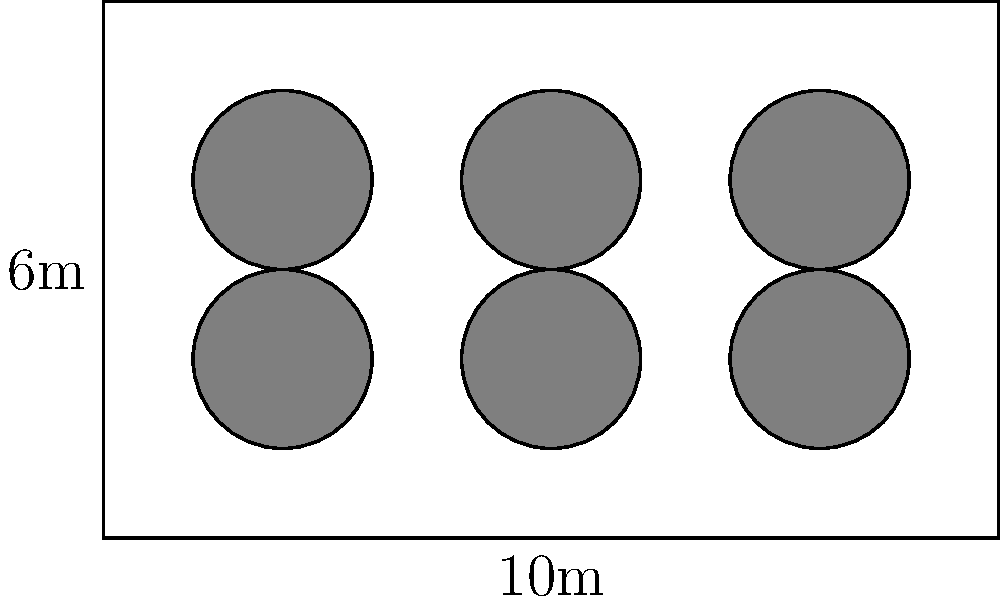You're planning a cultural event in a rectangular space measuring 10m by 6m. You want to arrange circular tables, each with a diameter of 2m, in a grid-like pattern. What is the maximum number of tables that can fit in this space while maintaining a minimum distance of 1m between each table and from the walls? To solve this problem, let's follow these steps:

1. Understand the space requirements:
   - The room is 10m x 6m
   - Each table has a diameter of 2m
   - We need 1m space between tables and from walls

2. Calculate the effective space needed for each table:
   - Diameter + minimum space = 2m + 1m = 3m
   - Each table effectively needs a 3m x 3m space

3. Calculate how many tables can fit along the length:
   - Room length = 10m
   - Number of tables along length = $\lfloor \frac{10}{3} \rfloor = 3$ (floor function)

4. Calculate how many tables can fit along the width:
   - Room width = 6m
   - Number of tables along width = $\lfloor \frac{6}{3} \rfloor = 2$ (floor function)

5. Calculate the total number of tables:
   - Total tables = tables along length × tables along width
   - Total tables = 3 × 2 = 6

Therefore, the maximum number of tables that can fit in the space while maintaining the required distances is 6.
Answer: 6 tables 